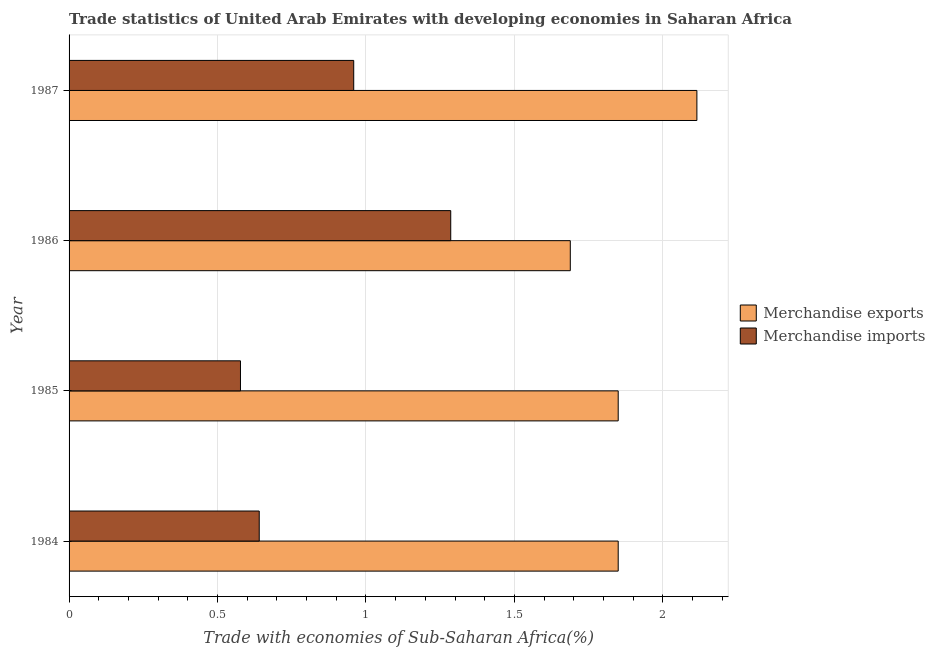How many different coloured bars are there?
Offer a terse response. 2. How many groups of bars are there?
Your response must be concise. 4. Are the number of bars per tick equal to the number of legend labels?
Provide a short and direct response. Yes. How many bars are there on the 2nd tick from the bottom?
Provide a succinct answer. 2. What is the label of the 2nd group of bars from the top?
Provide a succinct answer. 1986. In how many cases, is the number of bars for a given year not equal to the number of legend labels?
Offer a terse response. 0. What is the merchandise exports in 1987?
Offer a terse response. 2.11. Across all years, what is the maximum merchandise exports?
Make the answer very short. 2.11. Across all years, what is the minimum merchandise imports?
Make the answer very short. 0.58. What is the total merchandise imports in the graph?
Your answer should be compact. 3.46. What is the difference between the merchandise imports in 1984 and that in 1985?
Your answer should be very brief. 0.06. What is the difference between the merchandise imports in 1985 and the merchandise exports in 1987?
Your response must be concise. -1.54. What is the average merchandise exports per year?
Your response must be concise. 1.88. In the year 1985, what is the difference between the merchandise imports and merchandise exports?
Your answer should be compact. -1.27. What is the ratio of the merchandise exports in 1985 to that in 1986?
Provide a short and direct response. 1.1. Is the difference between the merchandise imports in 1984 and 1987 greater than the difference between the merchandise exports in 1984 and 1987?
Provide a short and direct response. No. What is the difference between the highest and the second highest merchandise imports?
Keep it short and to the point. 0.33. What is the difference between the highest and the lowest merchandise exports?
Give a very brief answer. 0.43. Are all the bars in the graph horizontal?
Your answer should be very brief. Yes. What is the difference between two consecutive major ticks on the X-axis?
Your answer should be compact. 0.5. Does the graph contain any zero values?
Provide a short and direct response. No. Does the graph contain grids?
Provide a succinct answer. Yes. How many legend labels are there?
Your response must be concise. 2. How are the legend labels stacked?
Provide a succinct answer. Vertical. What is the title of the graph?
Your answer should be compact. Trade statistics of United Arab Emirates with developing economies in Saharan Africa. What is the label or title of the X-axis?
Provide a succinct answer. Trade with economies of Sub-Saharan Africa(%). What is the Trade with economies of Sub-Saharan Africa(%) in Merchandise exports in 1984?
Your answer should be compact. 1.85. What is the Trade with economies of Sub-Saharan Africa(%) of Merchandise imports in 1984?
Offer a terse response. 0.64. What is the Trade with economies of Sub-Saharan Africa(%) in Merchandise exports in 1985?
Give a very brief answer. 1.85. What is the Trade with economies of Sub-Saharan Africa(%) of Merchandise imports in 1985?
Provide a succinct answer. 0.58. What is the Trade with economies of Sub-Saharan Africa(%) of Merchandise exports in 1986?
Give a very brief answer. 1.69. What is the Trade with economies of Sub-Saharan Africa(%) in Merchandise imports in 1986?
Ensure brevity in your answer.  1.29. What is the Trade with economies of Sub-Saharan Africa(%) in Merchandise exports in 1987?
Your answer should be compact. 2.11. What is the Trade with economies of Sub-Saharan Africa(%) of Merchandise imports in 1987?
Your response must be concise. 0.96. Across all years, what is the maximum Trade with economies of Sub-Saharan Africa(%) in Merchandise exports?
Give a very brief answer. 2.11. Across all years, what is the maximum Trade with economies of Sub-Saharan Africa(%) in Merchandise imports?
Ensure brevity in your answer.  1.29. Across all years, what is the minimum Trade with economies of Sub-Saharan Africa(%) of Merchandise exports?
Make the answer very short. 1.69. Across all years, what is the minimum Trade with economies of Sub-Saharan Africa(%) in Merchandise imports?
Ensure brevity in your answer.  0.58. What is the total Trade with economies of Sub-Saharan Africa(%) of Merchandise exports in the graph?
Your response must be concise. 7.5. What is the total Trade with economies of Sub-Saharan Africa(%) of Merchandise imports in the graph?
Your answer should be very brief. 3.46. What is the difference between the Trade with economies of Sub-Saharan Africa(%) of Merchandise exports in 1984 and that in 1985?
Offer a terse response. 0. What is the difference between the Trade with economies of Sub-Saharan Africa(%) of Merchandise imports in 1984 and that in 1985?
Offer a terse response. 0.06. What is the difference between the Trade with economies of Sub-Saharan Africa(%) of Merchandise exports in 1984 and that in 1986?
Provide a succinct answer. 0.16. What is the difference between the Trade with economies of Sub-Saharan Africa(%) of Merchandise imports in 1984 and that in 1986?
Provide a short and direct response. -0.65. What is the difference between the Trade with economies of Sub-Saharan Africa(%) of Merchandise exports in 1984 and that in 1987?
Your answer should be very brief. -0.27. What is the difference between the Trade with economies of Sub-Saharan Africa(%) of Merchandise imports in 1984 and that in 1987?
Keep it short and to the point. -0.32. What is the difference between the Trade with economies of Sub-Saharan Africa(%) in Merchandise exports in 1985 and that in 1986?
Keep it short and to the point. 0.16. What is the difference between the Trade with economies of Sub-Saharan Africa(%) of Merchandise imports in 1985 and that in 1986?
Give a very brief answer. -0.71. What is the difference between the Trade with economies of Sub-Saharan Africa(%) of Merchandise exports in 1985 and that in 1987?
Your response must be concise. -0.27. What is the difference between the Trade with economies of Sub-Saharan Africa(%) in Merchandise imports in 1985 and that in 1987?
Your answer should be compact. -0.38. What is the difference between the Trade with economies of Sub-Saharan Africa(%) of Merchandise exports in 1986 and that in 1987?
Your answer should be compact. -0.43. What is the difference between the Trade with economies of Sub-Saharan Africa(%) of Merchandise imports in 1986 and that in 1987?
Your response must be concise. 0.33. What is the difference between the Trade with economies of Sub-Saharan Africa(%) of Merchandise exports in 1984 and the Trade with economies of Sub-Saharan Africa(%) of Merchandise imports in 1985?
Your answer should be very brief. 1.27. What is the difference between the Trade with economies of Sub-Saharan Africa(%) in Merchandise exports in 1984 and the Trade with economies of Sub-Saharan Africa(%) in Merchandise imports in 1986?
Your answer should be very brief. 0.56. What is the difference between the Trade with economies of Sub-Saharan Africa(%) of Merchandise exports in 1984 and the Trade with economies of Sub-Saharan Africa(%) of Merchandise imports in 1987?
Offer a very short reply. 0.89. What is the difference between the Trade with economies of Sub-Saharan Africa(%) of Merchandise exports in 1985 and the Trade with economies of Sub-Saharan Africa(%) of Merchandise imports in 1986?
Keep it short and to the point. 0.56. What is the difference between the Trade with economies of Sub-Saharan Africa(%) in Merchandise exports in 1985 and the Trade with economies of Sub-Saharan Africa(%) in Merchandise imports in 1987?
Your answer should be compact. 0.89. What is the difference between the Trade with economies of Sub-Saharan Africa(%) of Merchandise exports in 1986 and the Trade with economies of Sub-Saharan Africa(%) of Merchandise imports in 1987?
Provide a short and direct response. 0.73. What is the average Trade with economies of Sub-Saharan Africa(%) in Merchandise exports per year?
Give a very brief answer. 1.88. What is the average Trade with economies of Sub-Saharan Africa(%) of Merchandise imports per year?
Your answer should be very brief. 0.87. In the year 1984, what is the difference between the Trade with economies of Sub-Saharan Africa(%) in Merchandise exports and Trade with economies of Sub-Saharan Africa(%) in Merchandise imports?
Give a very brief answer. 1.21. In the year 1985, what is the difference between the Trade with economies of Sub-Saharan Africa(%) of Merchandise exports and Trade with economies of Sub-Saharan Africa(%) of Merchandise imports?
Make the answer very short. 1.27. In the year 1986, what is the difference between the Trade with economies of Sub-Saharan Africa(%) of Merchandise exports and Trade with economies of Sub-Saharan Africa(%) of Merchandise imports?
Provide a short and direct response. 0.4. In the year 1987, what is the difference between the Trade with economies of Sub-Saharan Africa(%) of Merchandise exports and Trade with economies of Sub-Saharan Africa(%) of Merchandise imports?
Offer a terse response. 1.16. What is the ratio of the Trade with economies of Sub-Saharan Africa(%) of Merchandise exports in 1984 to that in 1985?
Provide a short and direct response. 1. What is the ratio of the Trade with economies of Sub-Saharan Africa(%) of Merchandise imports in 1984 to that in 1985?
Your answer should be compact. 1.11. What is the ratio of the Trade with economies of Sub-Saharan Africa(%) in Merchandise exports in 1984 to that in 1986?
Ensure brevity in your answer.  1.1. What is the ratio of the Trade with economies of Sub-Saharan Africa(%) of Merchandise imports in 1984 to that in 1986?
Provide a succinct answer. 0.5. What is the ratio of the Trade with economies of Sub-Saharan Africa(%) of Merchandise exports in 1984 to that in 1987?
Your response must be concise. 0.87. What is the ratio of the Trade with economies of Sub-Saharan Africa(%) of Merchandise imports in 1984 to that in 1987?
Provide a succinct answer. 0.67. What is the ratio of the Trade with economies of Sub-Saharan Africa(%) of Merchandise exports in 1985 to that in 1986?
Your answer should be very brief. 1.1. What is the ratio of the Trade with economies of Sub-Saharan Africa(%) of Merchandise imports in 1985 to that in 1986?
Ensure brevity in your answer.  0.45. What is the ratio of the Trade with economies of Sub-Saharan Africa(%) in Merchandise exports in 1985 to that in 1987?
Make the answer very short. 0.87. What is the ratio of the Trade with economies of Sub-Saharan Africa(%) in Merchandise imports in 1985 to that in 1987?
Offer a terse response. 0.6. What is the ratio of the Trade with economies of Sub-Saharan Africa(%) of Merchandise exports in 1986 to that in 1987?
Make the answer very short. 0.8. What is the ratio of the Trade with economies of Sub-Saharan Africa(%) in Merchandise imports in 1986 to that in 1987?
Provide a short and direct response. 1.34. What is the difference between the highest and the second highest Trade with economies of Sub-Saharan Africa(%) of Merchandise exports?
Make the answer very short. 0.27. What is the difference between the highest and the second highest Trade with economies of Sub-Saharan Africa(%) in Merchandise imports?
Provide a short and direct response. 0.33. What is the difference between the highest and the lowest Trade with economies of Sub-Saharan Africa(%) of Merchandise exports?
Offer a terse response. 0.43. What is the difference between the highest and the lowest Trade with economies of Sub-Saharan Africa(%) of Merchandise imports?
Offer a very short reply. 0.71. 